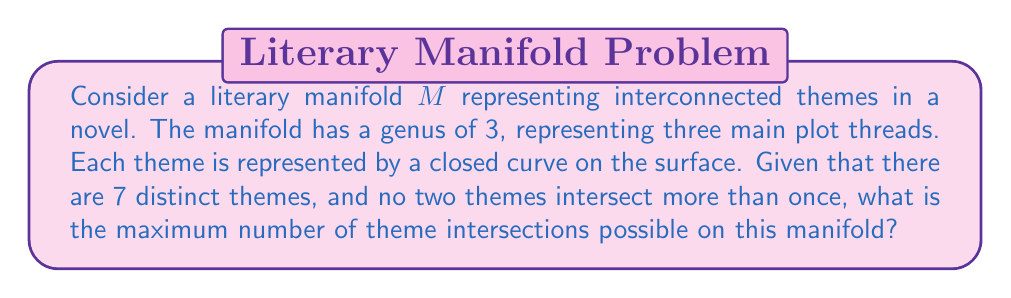What is the answer to this math problem? To solve this problem, we need to consider the topological properties of the manifold and apply concepts from graph theory:

1) The manifold $M$ has a genus of 3, which means it's topologically equivalent to a sphere with 3 handles.

2) Each theme is represented by a closed curve on the surface. These curves can be thought of as edges in a graph embedded on the manifold.

3) We have 7 distinct themes, so we're dealing with a graph with 7 vertices.

4) The maximum number of edges in a simple graph (no self-loops, no multiple edges between the same pair of vertices) with $n$ vertices is given by:

   $$\binom{n}{2} = \frac{n(n-1)}{2}$$

5) For 7 vertices, this would be:

   $$\binom{7}{2} = \frac{7 * 6}{2} = 21$$

6) However, we need to consider the genus of the manifold. The maximum number of edges for a graph embedded on a surface of genus $g$ without crossings is given by Euler's formula:

   $$e \leq 3n + 6(g-1)$$

   where $e$ is the number of edges and $n$ is the number of vertices.

7) In our case, $n = 7$ and $g = 3$, so:

   $$e \leq 3(7) + 6(3-1) = 21 + 12 = 33$$

8) Each intersection represents an edge in our graph. Since the maximum number of edges (33) is greater than the maximum number of edges in a simple graph with 7 vertices (21), we can achieve the maximum of 21 intersections.

Therefore, the maximum number of theme intersections possible on this manifold is 21.
Answer: 21 intersections 